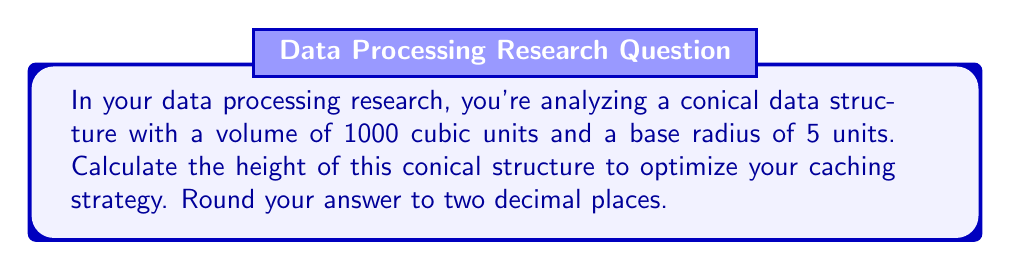Show me your answer to this math problem. Let's approach this step-by-step using the formula for the volume of a cone:

1) The formula for the volume of a cone is:
   $$V = \frac{1}{3}\pi r^2 h$$
   where $V$ is volume, $r$ is radius of the base, and $h$ is height.

2) We're given:
   $V = 1000$ cubic units
   $r = 5$ units

3) Substitute these values into the formula:
   $$1000 = \frac{1}{3}\pi (5^2) h$$

4) Simplify:
   $$1000 = \frac{1}{3}\pi (25) h$$
   $$1000 = \frac{25\pi}{3} h$$

5) Solve for $h$:
   $$h = \frac{1000 \cdot 3}{25\pi}$$
   $$h = \frac{3000}{25\pi}$$

6) Calculate and round to two decimal places:
   $$h \approx 38.20$$ units

This height optimization can help in designing efficient caching strategies for your conical data structure.
Answer: $38.20$ units 